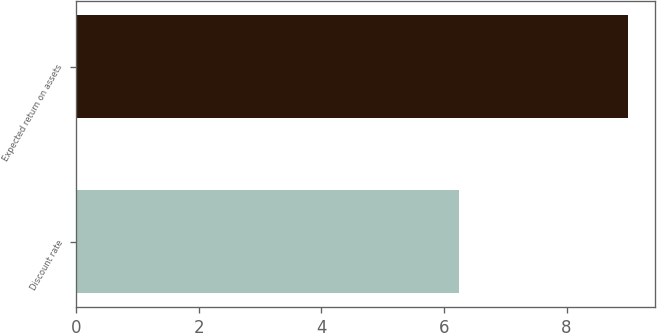Convert chart. <chart><loc_0><loc_0><loc_500><loc_500><bar_chart><fcel>Discount rate<fcel>Expected return on assets<nl><fcel>6.25<fcel>9<nl></chart> 